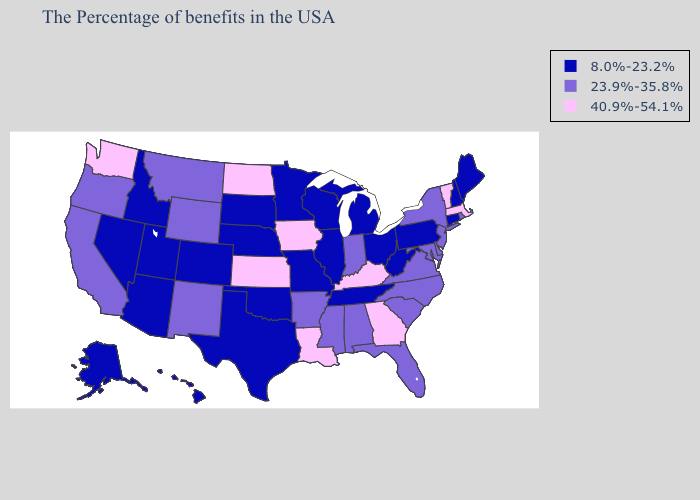Among the states that border New Mexico , which have the highest value?
Short answer required. Oklahoma, Texas, Colorado, Utah, Arizona. Name the states that have a value in the range 40.9%-54.1%?
Keep it brief. Massachusetts, Vermont, Georgia, Kentucky, Louisiana, Iowa, Kansas, North Dakota, Washington. Does Illinois have a higher value than Utah?
Concise answer only. No. What is the highest value in the USA?
Concise answer only. 40.9%-54.1%. Among the states that border Texas , which have the lowest value?
Keep it brief. Oklahoma. Does Kentucky have the highest value in the South?
Write a very short answer. Yes. Among the states that border Delaware , does Pennsylvania have the lowest value?
Short answer required. Yes. Among the states that border Mississippi , which have the lowest value?
Write a very short answer. Tennessee. Does the first symbol in the legend represent the smallest category?
Keep it brief. Yes. Does New York have the lowest value in the Northeast?
Write a very short answer. No. Name the states that have a value in the range 8.0%-23.2%?
Quick response, please. Maine, New Hampshire, Connecticut, Pennsylvania, West Virginia, Ohio, Michigan, Tennessee, Wisconsin, Illinois, Missouri, Minnesota, Nebraska, Oklahoma, Texas, South Dakota, Colorado, Utah, Arizona, Idaho, Nevada, Alaska, Hawaii. Name the states that have a value in the range 23.9%-35.8%?
Be succinct. Rhode Island, New York, New Jersey, Delaware, Maryland, Virginia, North Carolina, South Carolina, Florida, Indiana, Alabama, Mississippi, Arkansas, Wyoming, New Mexico, Montana, California, Oregon. Which states have the lowest value in the USA?
Short answer required. Maine, New Hampshire, Connecticut, Pennsylvania, West Virginia, Ohio, Michigan, Tennessee, Wisconsin, Illinois, Missouri, Minnesota, Nebraska, Oklahoma, Texas, South Dakota, Colorado, Utah, Arizona, Idaho, Nevada, Alaska, Hawaii. What is the value of Hawaii?
Write a very short answer. 8.0%-23.2%. 